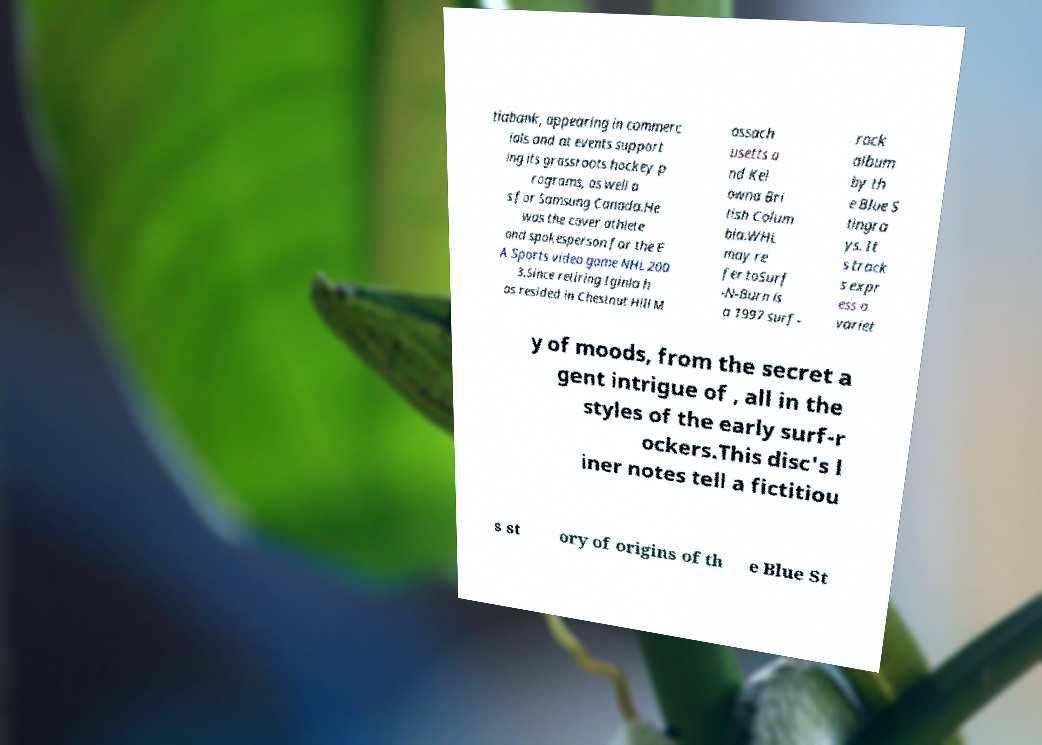Can you read and provide the text displayed in the image?This photo seems to have some interesting text. Can you extract and type it out for me? tiabank, appearing in commerc ials and at events support ing its grassroots hockey p rograms, as well a s for Samsung Canada.He was the cover athlete and spokesperson for the E A Sports video game NHL 200 3.Since retiring Iginla h as resided in Chestnut Hill M assach usetts a nd Kel owna Bri tish Colum bia.WHL may re fer toSurf -N-Burn is a 1997 surf- rock album by th e Blue S tingra ys. It s track s expr ess a variet y of moods, from the secret a gent intrigue of , all in the styles of the early surf-r ockers.This disc's l iner notes tell a fictitiou s st ory of origins of th e Blue St 